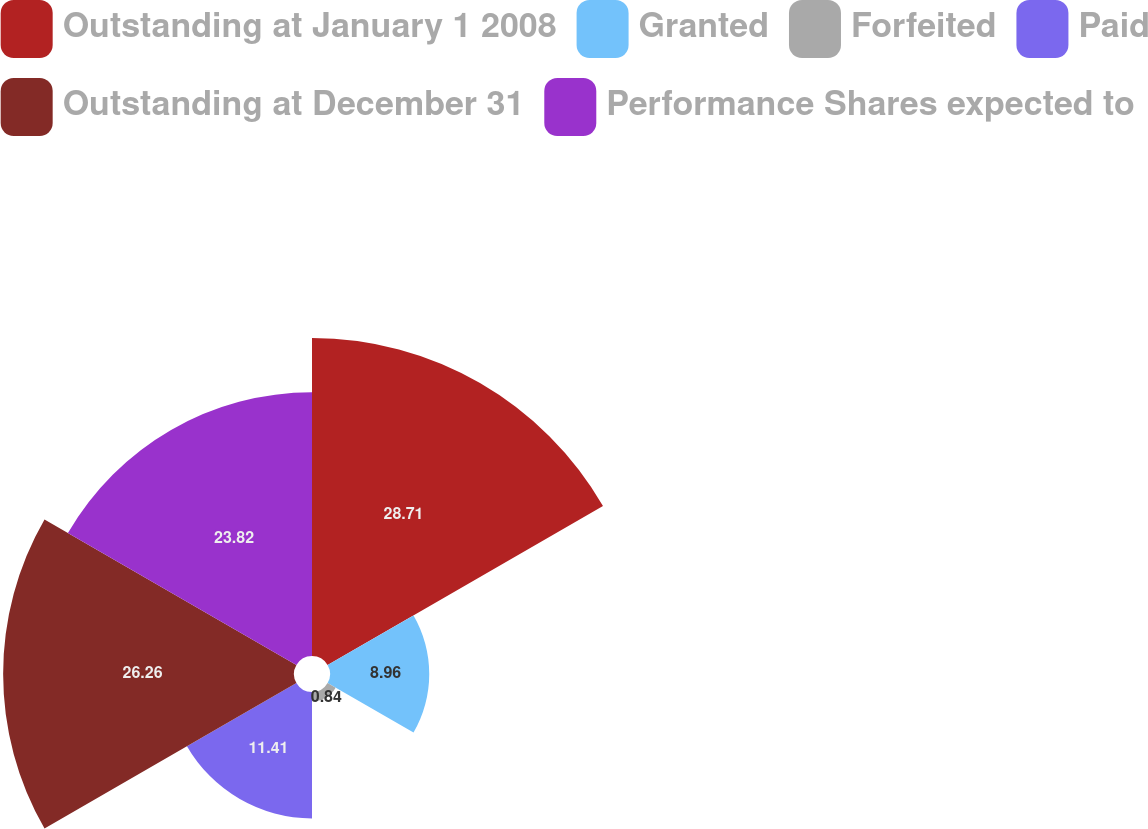Convert chart to OTSL. <chart><loc_0><loc_0><loc_500><loc_500><pie_chart><fcel>Outstanding at January 1 2008<fcel>Granted<fcel>Forfeited<fcel>Paid<fcel>Outstanding at December 31<fcel>Performance Shares expected to<nl><fcel>28.71%<fcel>8.96%<fcel>0.84%<fcel>11.41%<fcel>26.26%<fcel>23.82%<nl></chart> 